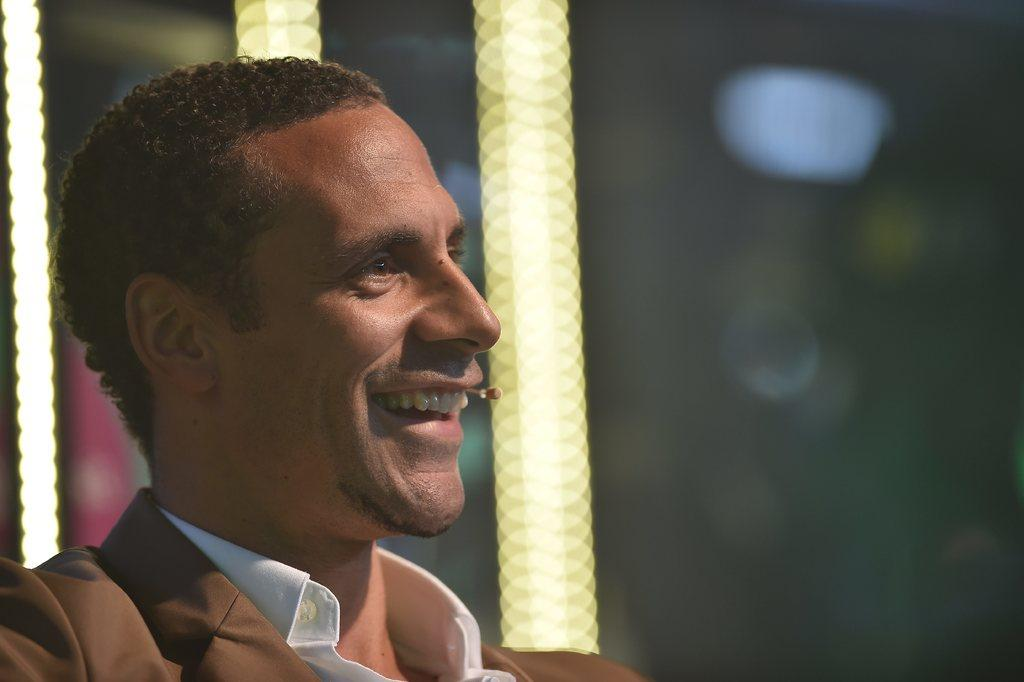What is the main subject in the foreground of the image? There is a person in the foreground of the image. What is the person doing or expressing in the image? The person is smiling. Can you describe the background of the image? The background of the image is blurred. What type of part can be seen in the basin in the image? There is no basin or part present in the image; it features a person in the foreground with a blurred background. 